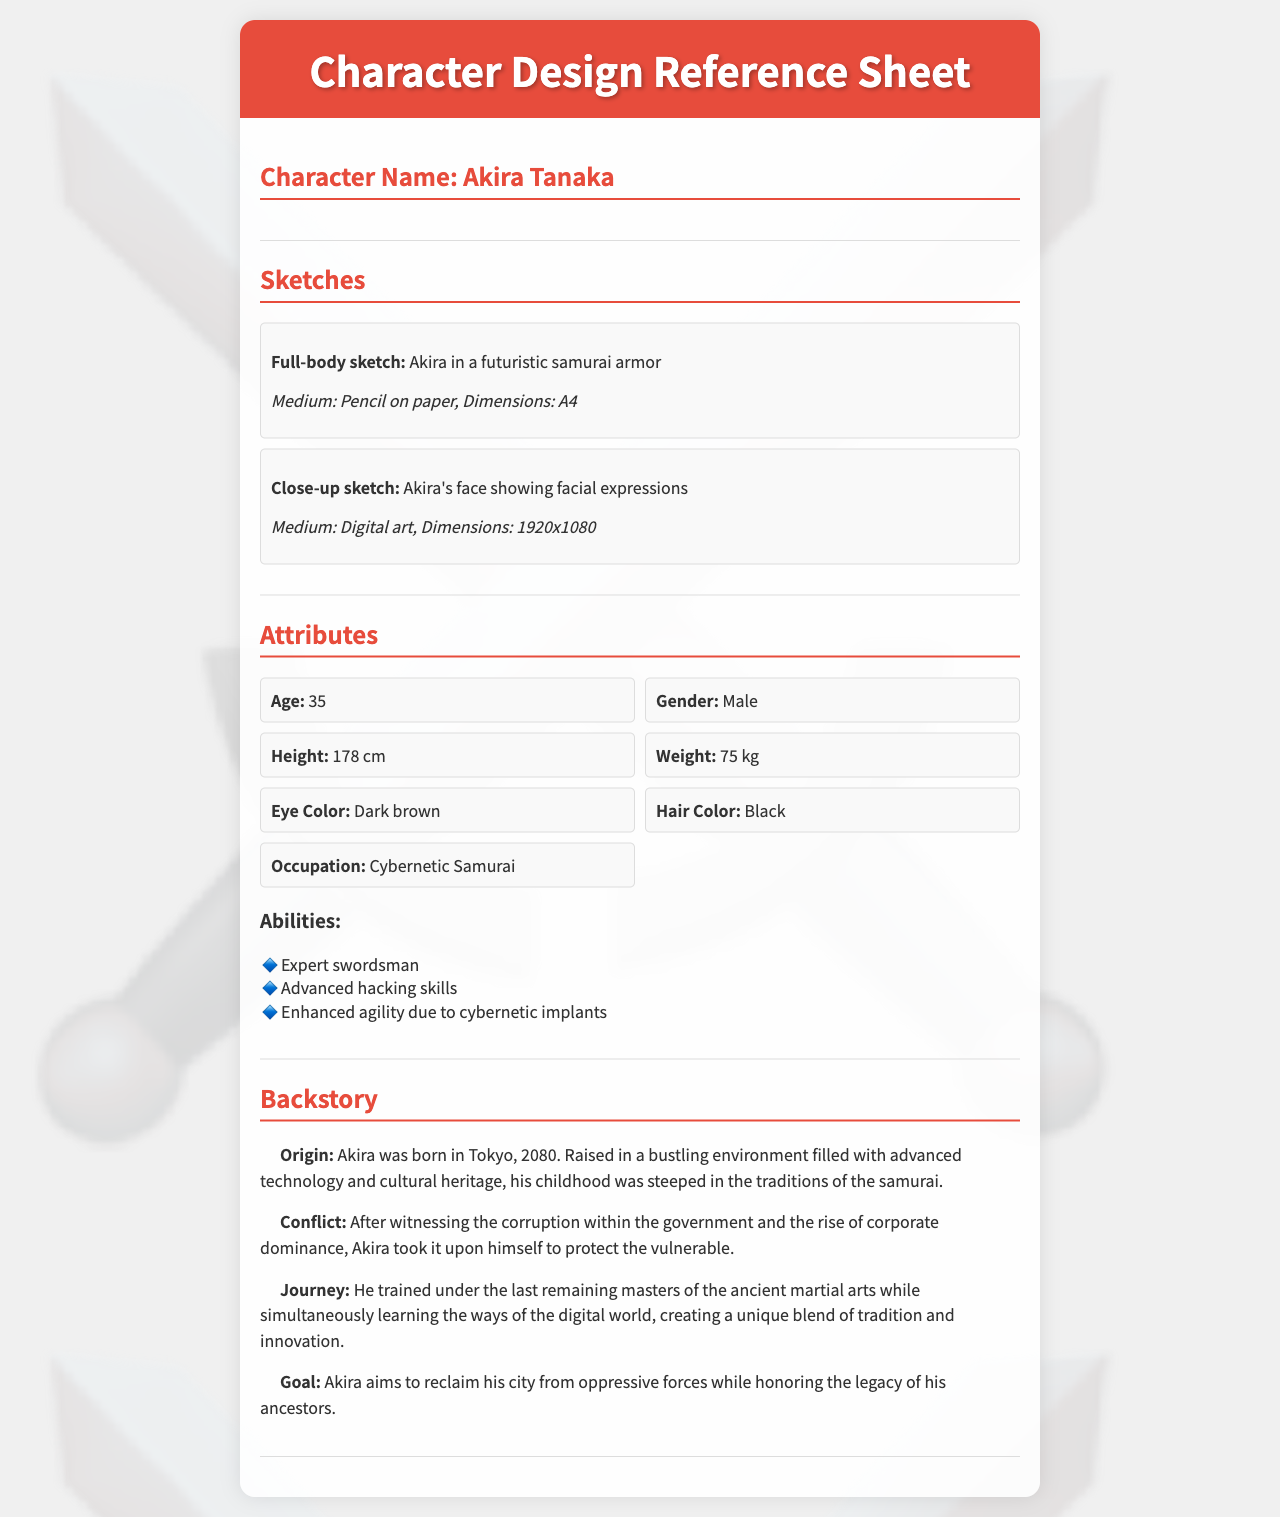What is the character's name? The character's name is clearly stated at the beginning of the reference sheet.
Answer: Akira Tanaka How old is Akira? The age of Akira is listed as one of the attributes in the document.
Answer: 35 What is Akira's occupation? The occupation is specified under the attributes section of the document.
Answer: Cybernetic Samurai What color are Akira's eyes? The eye color of Akira is mentioned in the attributes section.
Answer: Dark brown What year was Akira born? The year of Akira's birth is referenced in the backstory section.
Answer: 2080 What is one of Akira's abilities? The abilities of Akira are listed under the abilities section, which has multiple items.
Answer: Expert swordsman What does Akira aim to reclaim? The goal of Akira, as stated in his backstory, outlines his main objective.
Answer: His city What training did Akira undergo? The journey section describes the type of training Akira received in detail.
Answer: Martial arts What medium was used for the full-body sketch? The medium for the full-body sketch is described in the sketches section of the document.
Answer: Pencil on paper 